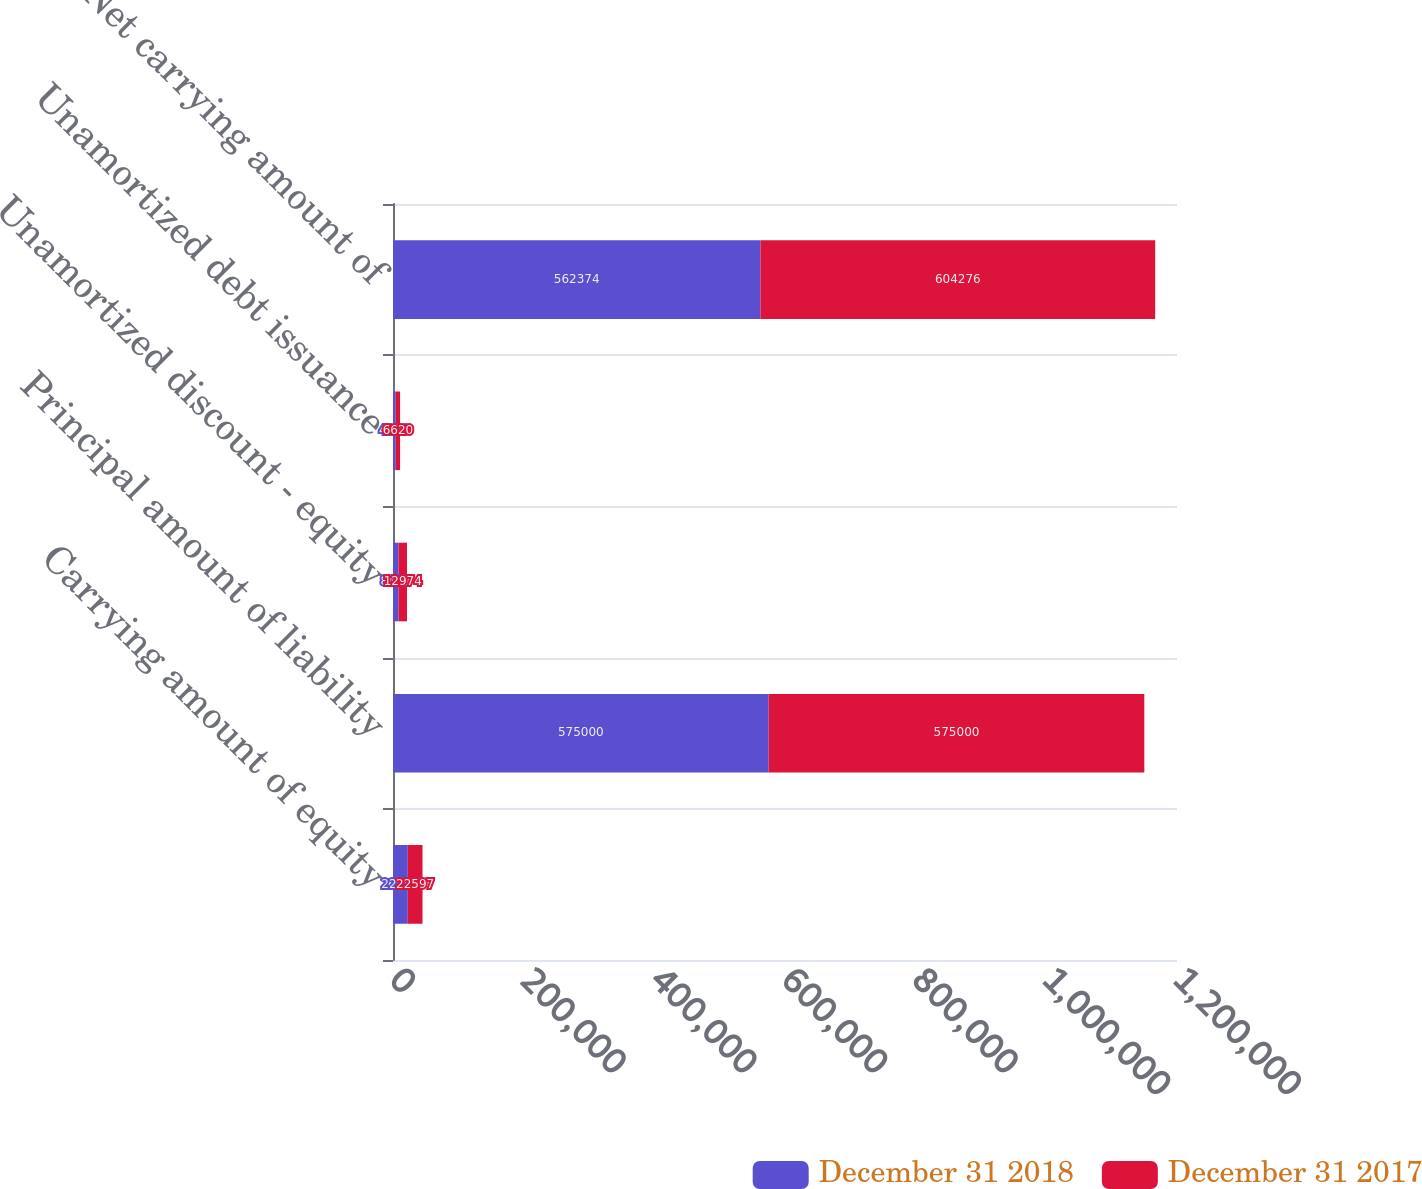Convert chart to OTSL. <chart><loc_0><loc_0><loc_500><loc_500><stacked_bar_chart><ecel><fcel>Carrying amount of equity<fcel>Principal amount of liability<fcel>Unamortized discount - equity<fcel>Unamortized debt issuance<fcel>Net carrying amount of<nl><fcel>December 31 2018<fcel>22597<fcel>575000<fcel>8417<fcel>4209<fcel>562374<nl><fcel>December 31 2017<fcel>22597<fcel>575000<fcel>12974<fcel>6620<fcel>604276<nl></chart> 